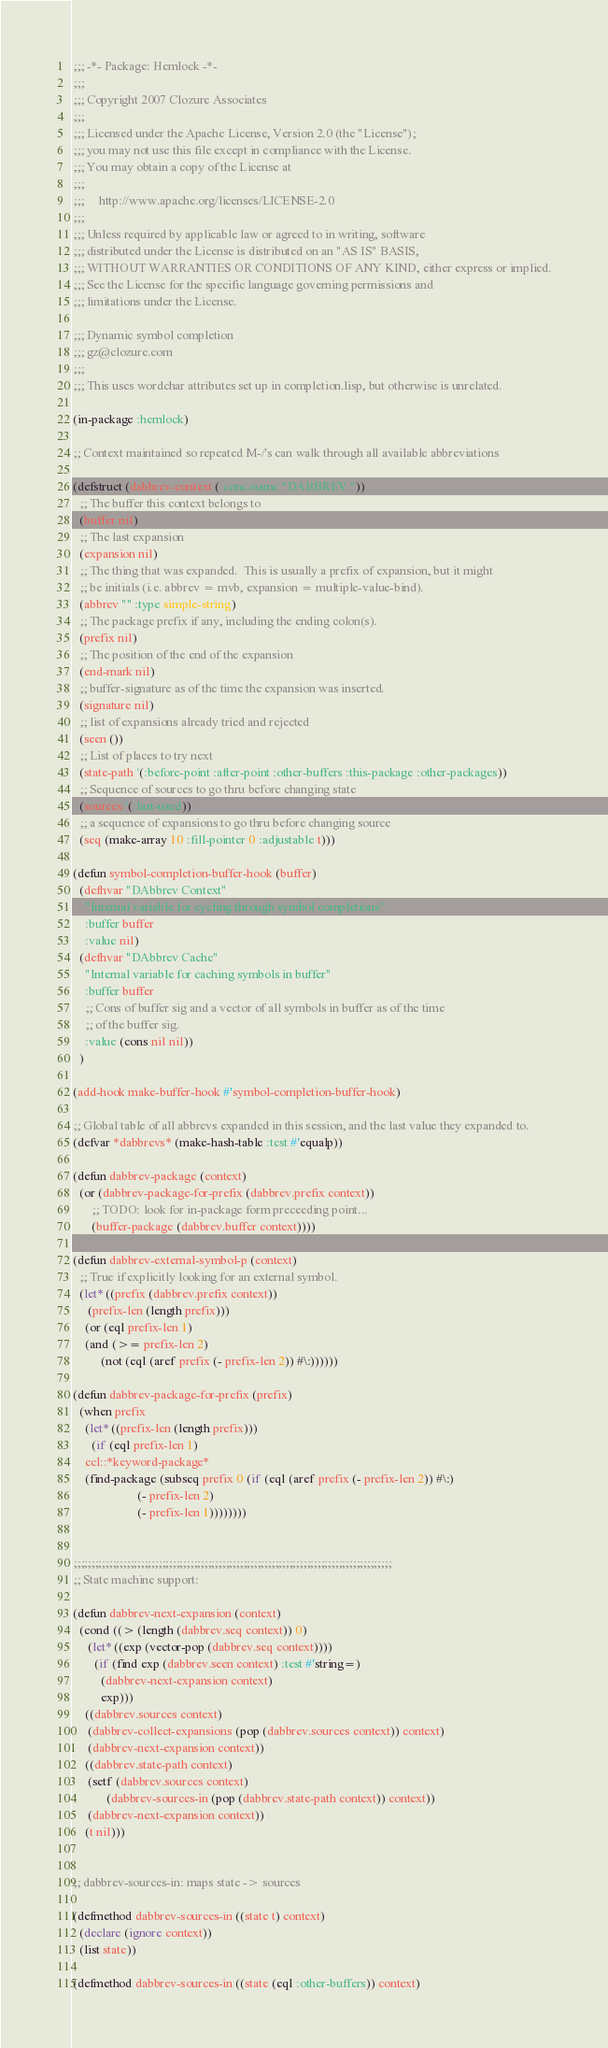Convert code to text. <code><loc_0><loc_0><loc_500><loc_500><_Lisp_>;;; -*- Package: Hemlock -*-
;;;
;;; Copyright 2007 Clozure Associates
;;;
;;; Licensed under the Apache License, Version 2.0 (the "License");
;;; you may not use this file except in compliance with the License.
;;; You may obtain a copy of the License at
;;;
;;;     http://www.apache.org/licenses/LICENSE-2.0
;;;
;;; Unless required by applicable law or agreed to in writing, software
;;; distributed under the License is distributed on an "AS IS" BASIS,
;;; WITHOUT WARRANTIES OR CONDITIONS OF ANY KIND, either express or implied.
;;; See the License for the specific language governing permissions and
;;; limitations under the License.

;;; Dynamic symbol completion
;;; gz@clozure.com
;;;
;;; This uses wordchar attributes set up in completion.lisp, but otherwise is unrelated.

(in-package :hemlock)

;; Context maintained so repeated M-/'s can walk through all available abbreviations

(defstruct (dabbrev-context (:conc-name "DABBREV."))
  ;; The buffer this context belongs to
  (buffer nil)
  ;; The last expansion
  (expansion nil)
  ;; The thing that was expanded.  This is usually a prefix of expansion, but it might
  ;; be initials (i.e. abbrev = mvb, expansion = multiple-value-bind).
  (abbrev "" :type simple-string)
  ;; The package prefix if any, including the ending colon(s).
  (prefix nil)
  ;; The position of the end of the expansion
  (end-mark nil)
  ;; buffer-signature as of the time the expansion was inserted.
  (signature nil)
  ;; list of expansions already tried and rejected
  (seen ())
  ;; List of places to try next
  (state-path '(:before-point :after-point :other-buffers :this-package :other-packages))
  ;; Sequence of sources to go thru before changing state
  (sources '(:last-used))
  ;; a sequence of expansions to go thru before changing source
  (seq (make-array 10 :fill-pointer 0 :adjustable t)))

(defun symbol-completion-buffer-hook (buffer)
  (defhvar "DAbbrev Context"
    "Internal variable for cycling through symbol completions"
    :buffer buffer
    :value nil)
  (defhvar "DAbbrev Cache"
    "Internal variable for caching symbols in buffer"
    :buffer buffer
    ;; Cons of buffer sig and a vector of all symbols in buffer as of the time
    ;; of the buffer sig.
    :value (cons nil nil))
  )

(add-hook make-buffer-hook #'symbol-completion-buffer-hook)

;; Global table of all abbrevs expanded in this session, and the last value they expanded to.
(defvar *dabbrevs* (make-hash-table :test #'equalp))

(defun dabbrev-package (context)
  (or (dabbrev-package-for-prefix (dabbrev.prefix context))
      ;; TODO: look for in-package form preceeding point...
      (buffer-package (dabbrev.buffer context))))

(defun dabbrev-external-symbol-p (context)
  ;; True if explicitly looking for an external symbol.
  (let* ((prefix (dabbrev.prefix context))
	 (prefix-len (length prefix)))
    (or (eql prefix-len 1)
	(and (>= prefix-len 2)
	     (not (eql (aref prefix (- prefix-len 2)) #\:))))))

(defun dabbrev-package-for-prefix (prefix)
  (when prefix
    (let* ((prefix-len (length prefix)))
      (if (eql prefix-len 1)
	ccl::*keyword-package*
	(find-package (subseq prefix 0 (if (eql (aref prefix (- prefix-len 2)) #\:)
					 (- prefix-len 2)
					 (- prefix-len 1))))))))


;;;;;;;;;;;;;;;;;;;;;;;;;;;;;;;;;;;;;;;;;;;;;;;;;;;;;;;;;;;;;;;;;;;;;;;;;;;;;;;;;;;;;;;;;;
;; State machine support:

(defun dabbrev-next-expansion (context)
  (cond ((> (length (dabbrev.seq context)) 0)
	 (let* ((exp (vector-pop (dabbrev.seq context))))
	   (if (find exp (dabbrev.seen context) :test #'string=)
	     (dabbrev-next-expansion context)
	     exp)))
	((dabbrev.sources context)
	 (dabbrev-collect-expansions (pop (dabbrev.sources context)) context)
	 (dabbrev-next-expansion context))
	((dabbrev.state-path context)
	 (setf (dabbrev.sources context)
	       (dabbrev-sources-in (pop (dabbrev.state-path context)) context))
	 (dabbrev-next-expansion context))
	(t nil)))


;; dabbrev-sources-in: maps state -> sources

(defmethod dabbrev-sources-in ((state t) context)
  (declare (ignore context))
  (list state))

(defmethod dabbrev-sources-in ((state (eql :other-buffers)) context)</code> 